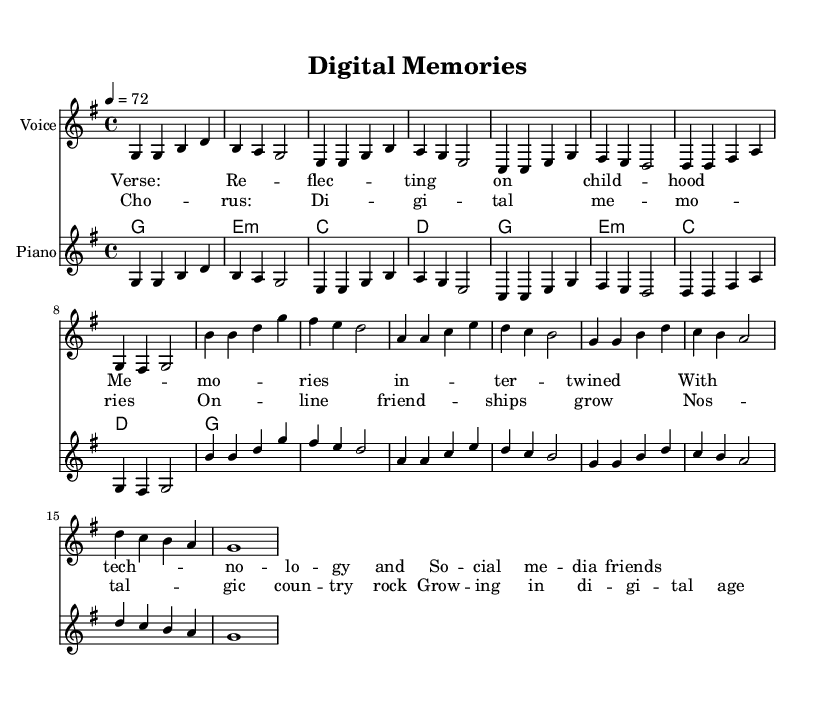What is the key signature of this music? The key is G major, which has one sharp (F#) indicated in the key signature.
Answer: G major What is the time signature of this music? The time signature is 4/4, which means there are four beats per measure and a quarter note receives one beat.
Answer: 4/4 What is the tempo marking of this music? The tempo marking is 72 beats per minute, indicated at the beginning of the score.
Answer: 72 How many verses are in the song? There is one verse and one chorus, and the music indicates the order: verse followed by the chorus.
Answer: One verse What is the chord progression used in the verse? The chord progression in the verse consists of G, E minor, C, and D. This sequence creates a typical country-rock feel.
Answer: G, E minor, C, D How does the chorus relate to the verse in structure? The chorus is structured similarly to the verse; both have a melodic line supported by chords, making it cohesive while offering a contrast in thematic expression.
Answer: Similar structure What thematic element is highlighted in the lyrics of this song? The lyrics highlight the theme of growing up in the digital age, blending nostalgia with modern technology influences.
Answer: Nostalgia and technology 